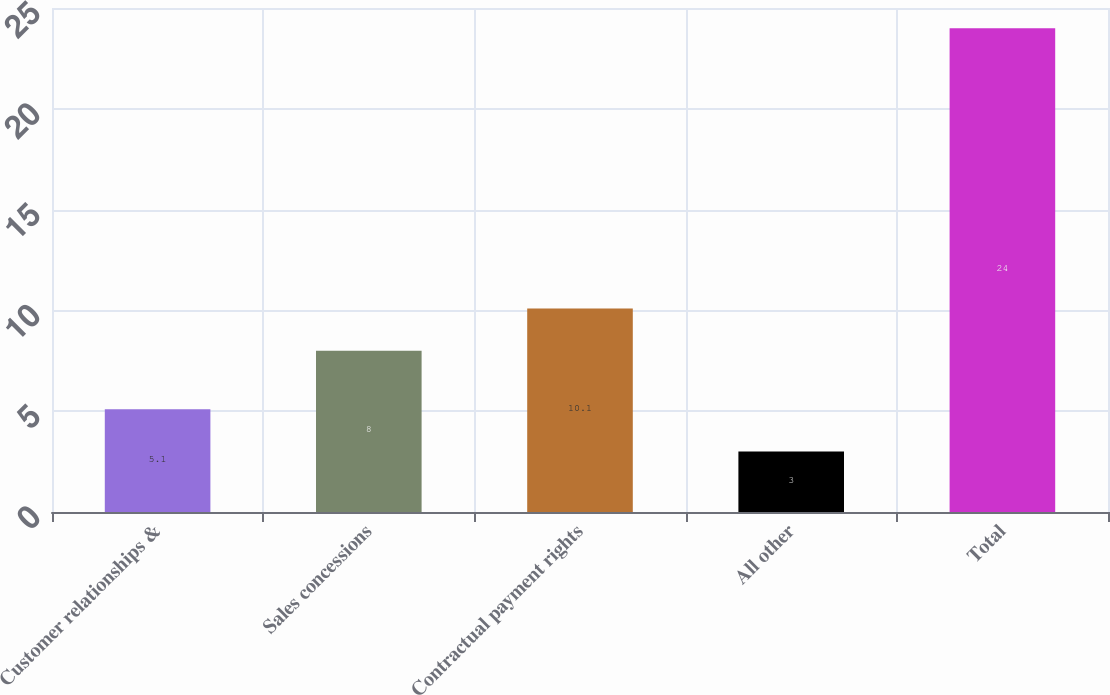Convert chart. <chart><loc_0><loc_0><loc_500><loc_500><bar_chart><fcel>Customer relationships &<fcel>Sales concessions<fcel>Contractual payment rights<fcel>All other<fcel>Total<nl><fcel>5.1<fcel>8<fcel>10.1<fcel>3<fcel>24<nl></chart> 